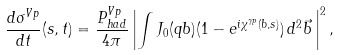<formula> <loc_0><loc_0><loc_500><loc_500>\frac { d \sigma ^ { V p } } { d t } ( s , t ) = \frac { P _ { h a d } ^ { V p } } { 4 \pi } \left | \int J _ { 0 } ( q b ) ( 1 - e ^ { i \chi ^ { \gamma p } ( b , s ) } ) \, d ^ { 2 } \vec { b } \, \right | ^ { 2 } ,</formula> 